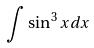<formula> <loc_0><loc_0><loc_500><loc_500>\int \sin ^ { 3 } x d x</formula> 